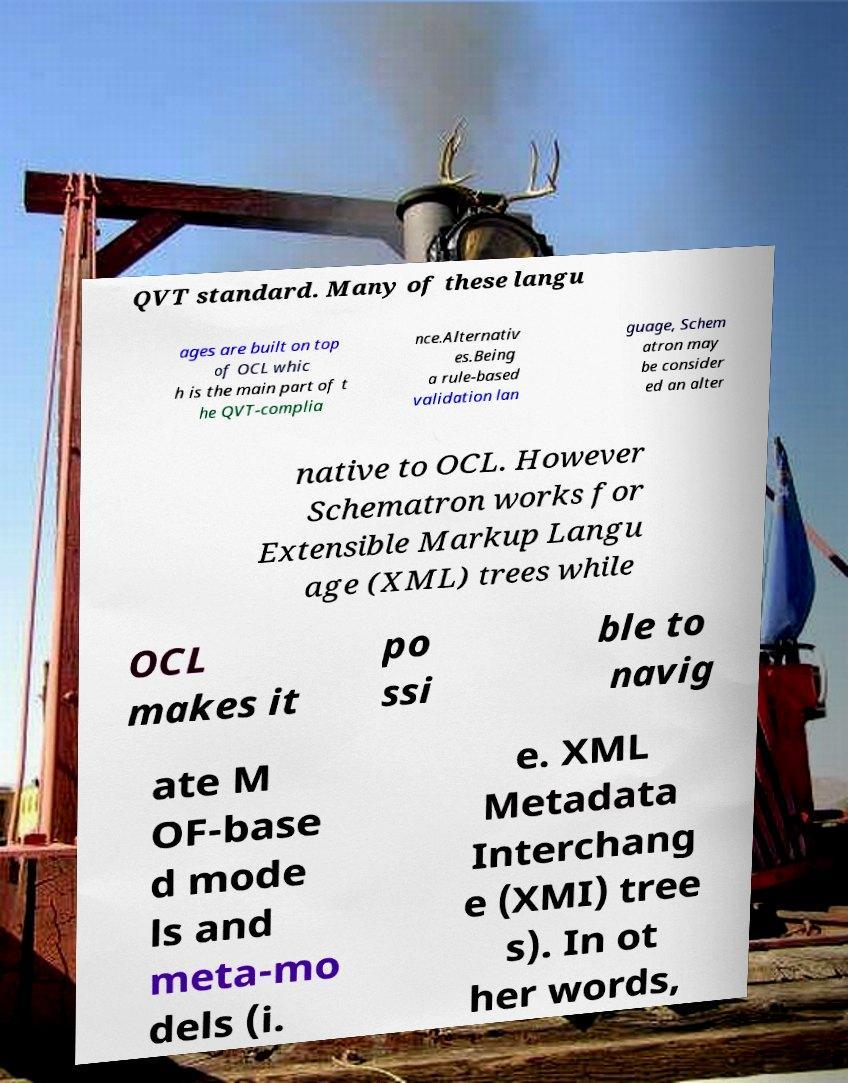Could you extract and type out the text from this image? QVT standard. Many of these langu ages are built on top of OCL whic h is the main part of t he QVT-complia nce.Alternativ es.Being a rule-based validation lan guage, Schem atron may be consider ed an alter native to OCL. However Schematron works for Extensible Markup Langu age (XML) trees while OCL makes it po ssi ble to navig ate M OF-base d mode ls and meta-mo dels (i. e. XML Metadata Interchang e (XMI) tree s). In ot her words, 